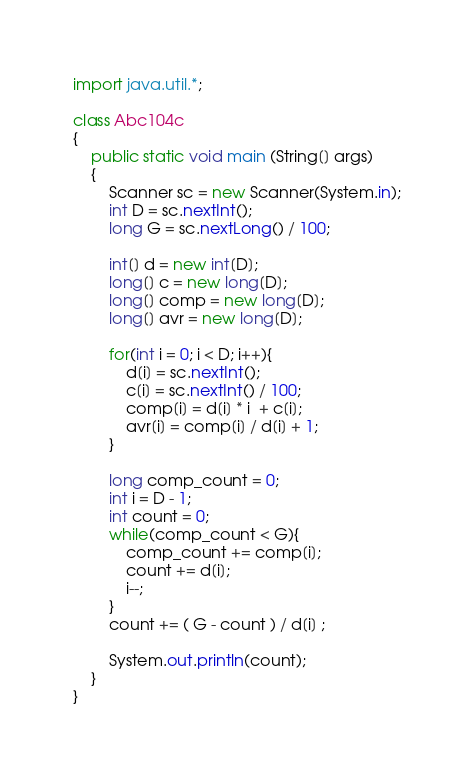<code> <loc_0><loc_0><loc_500><loc_500><_Java_>import java.util.*;

class Abc104c
{
    public static void main (String[] args)
    {
        Scanner sc = new Scanner(System.in);
        int D = sc.nextInt();
        long G = sc.nextLong() / 100;

        int[] d = new int[D];
        long[] c = new long[D];
        long[] comp = new long[D];
        long[] avr = new long[D];

        for(int i = 0; i < D; i++){
            d[i] = sc.nextInt();
            c[i] = sc.nextInt() / 100;
            comp[i] = d[i] * i  + c[i];
            avr[i] = comp[i] / d[i] + 1;
        }

        long comp_count = 0;
        int i = D - 1;
        int count = 0;
        while(comp_count < G){
            comp_count += comp[i];
            count += d[i];
            i--;
        }
        count += ( G - count ) / d[i] ;

        System.out.println(count);
    }
}</code> 